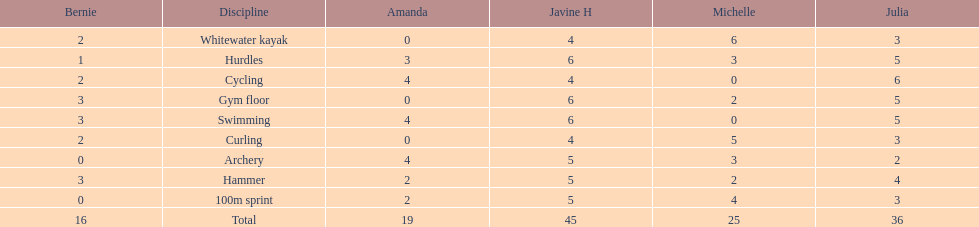Who had her best score in cycling? Julia. 